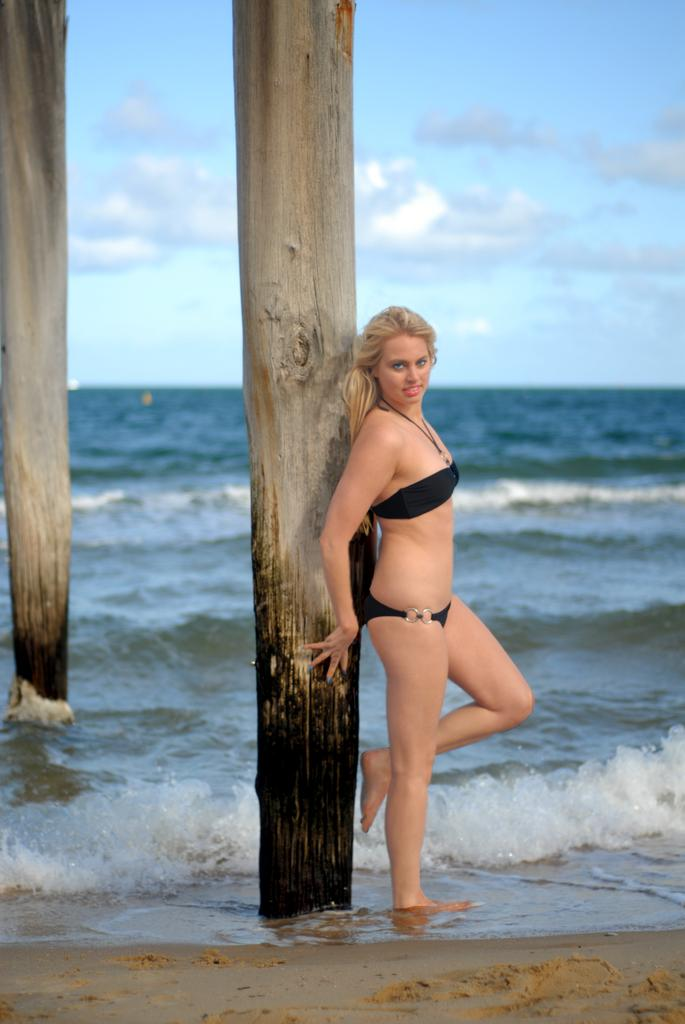What is located in the center of the image? There are poles in the center of the image. What is the person near the poles doing? The person is standing near the poles. What is the expression on the person's face? The person is smiling. What can be seen in the background of the image? The sky, clouds, and water are visible in the background of the image. How many owls are sitting on the poles in the image? There are no owls present in the image; it only features poles and a person. What is the person's income in the image? There is no information about the person's income in the image. 